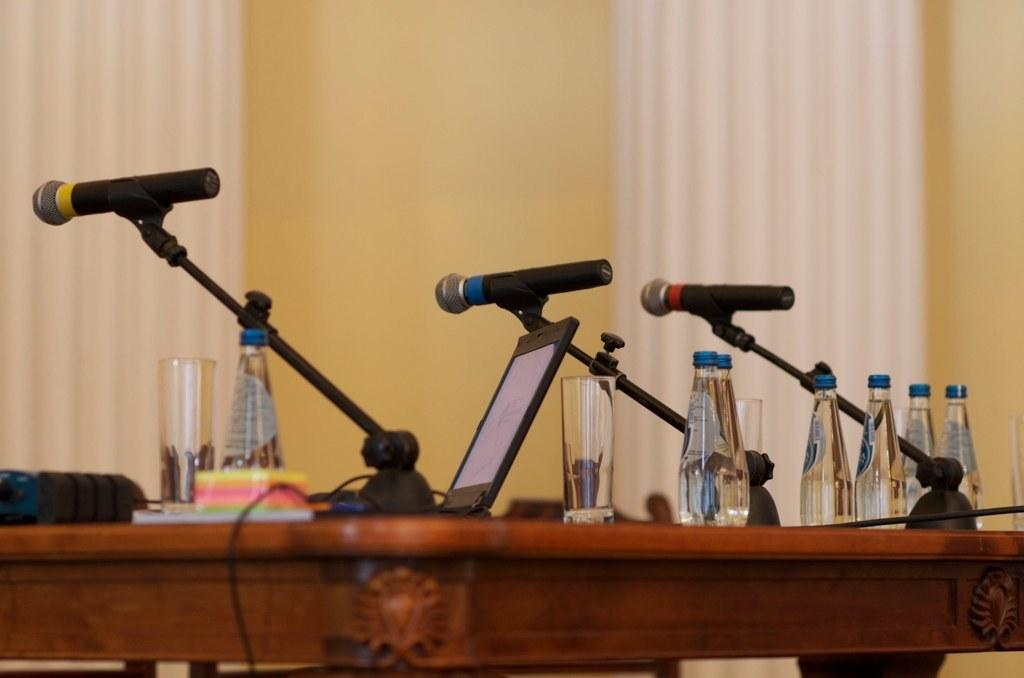What type of window treatment is visible in the image? There are curtains in the image. What color is the wall in the image? The wall in the image is yellow. What piece of furniture is present in the image? There is a table in the image. What electronic device is on the table? There is a tablet on the table. What else can be seen on the table? There are bottles and a microphone (mike's) on the table. How many fowl are present in the image? There are no fowl present in the image. What type of footwear is visible in the image? There is no footwear visible in the image. 